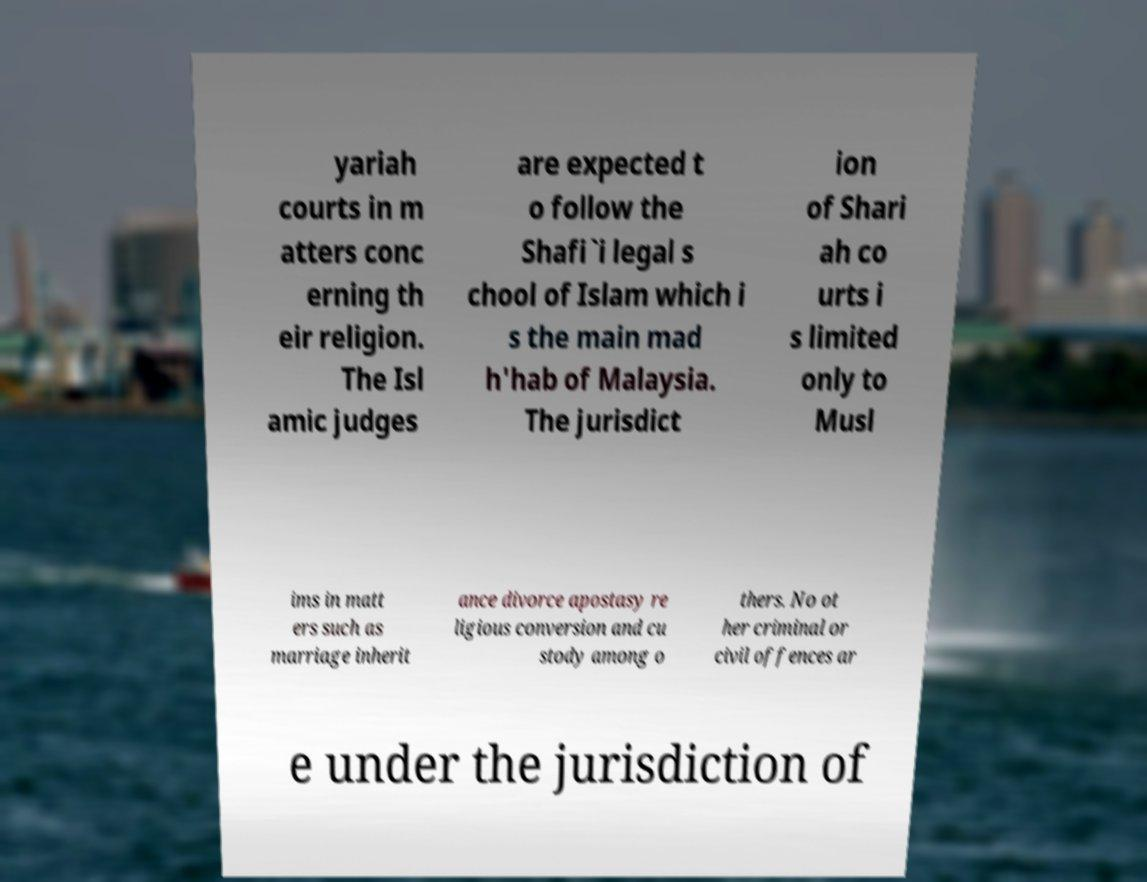Please read and relay the text visible in this image. What does it say? yariah courts in m atters conc erning th eir religion. The Isl amic judges are expected t o follow the Shafi`i legal s chool of Islam which i s the main mad h'hab of Malaysia. The jurisdict ion of Shari ah co urts i s limited only to Musl ims in matt ers such as marriage inherit ance divorce apostasy re ligious conversion and cu stody among o thers. No ot her criminal or civil offences ar e under the jurisdiction of 